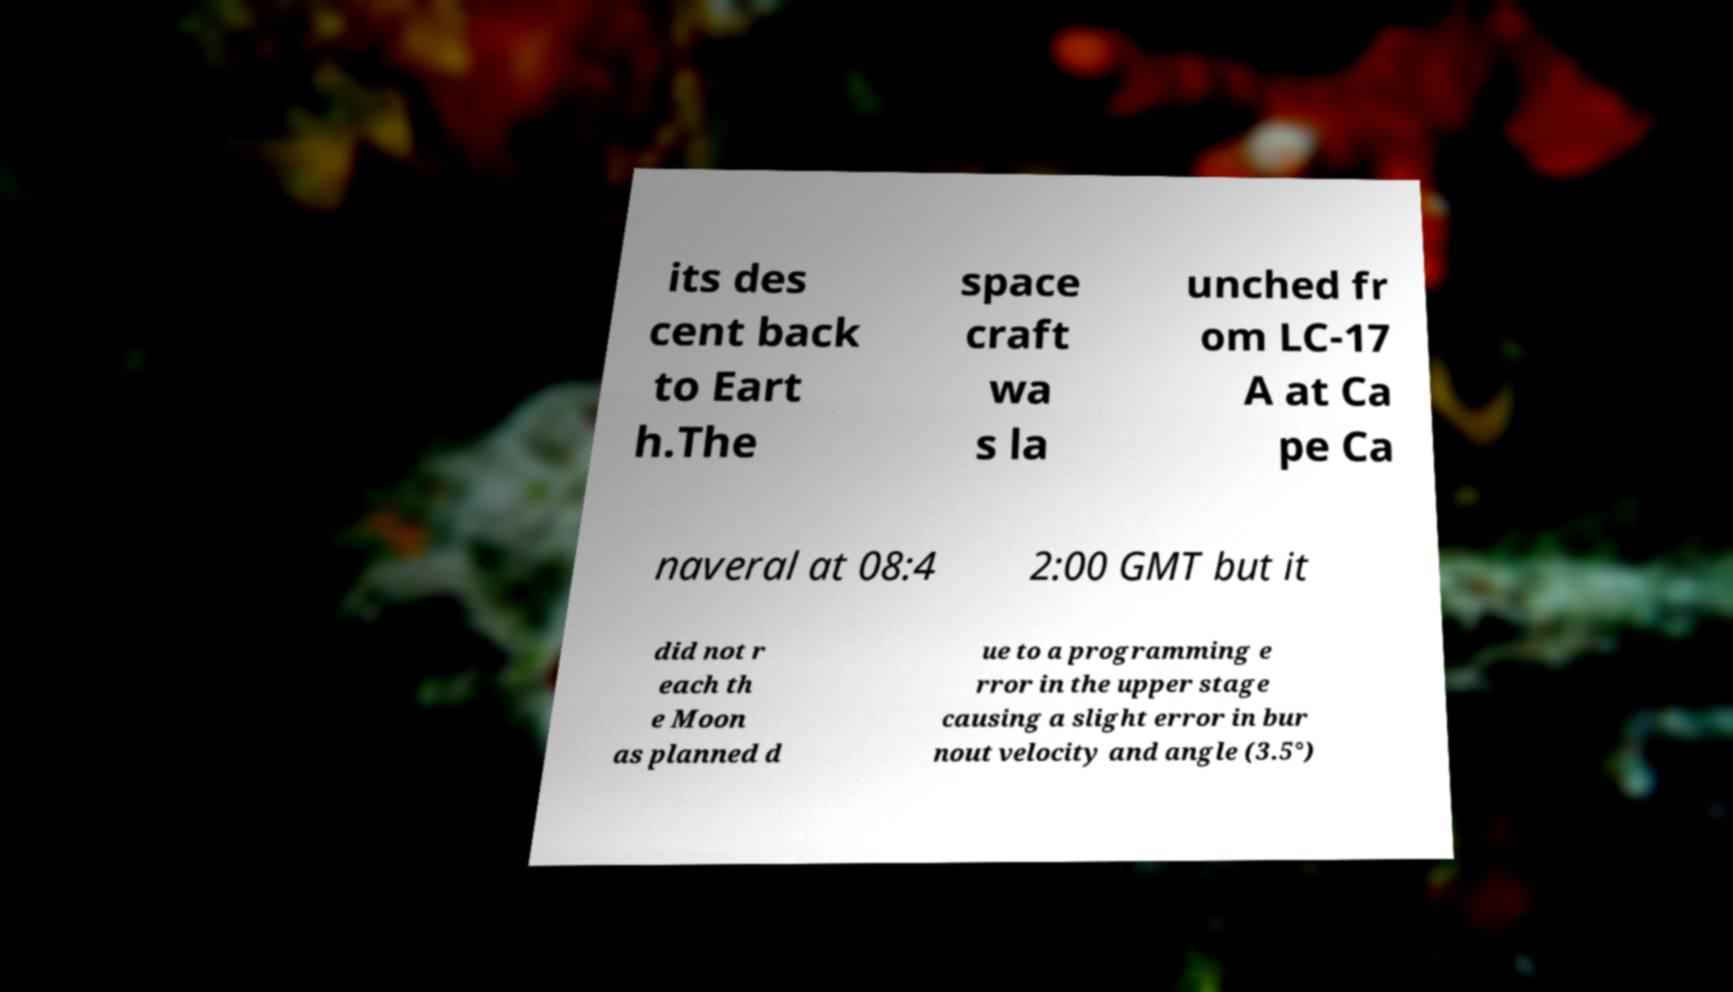Please read and relay the text visible in this image. What does it say? its des cent back to Eart h.The space craft wa s la unched fr om LC-17 A at Ca pe Ca naveral at 08:4 2:00 GMT but it did not r each th e Moon as planned d ue to a programming e rror in the upper stage causing a slight error in bur nout velocity and angle (3.5°) 